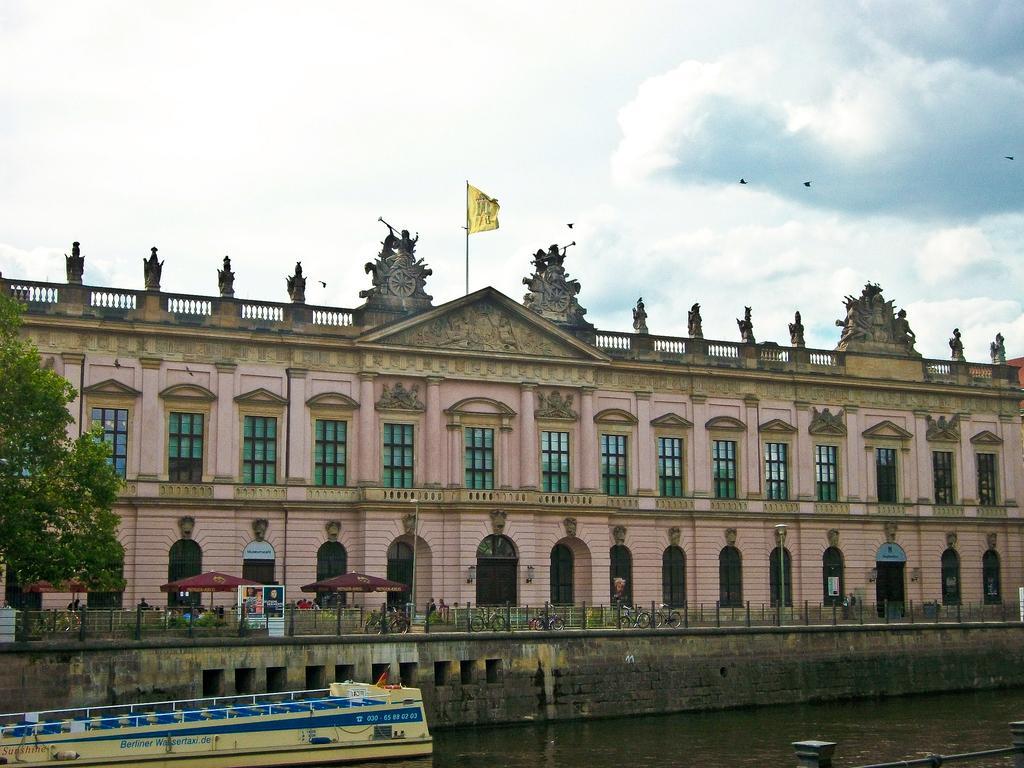Please provide a concise description of this image. In the center of the image there is a building. At the bottom of the image we can see road, tents, persons, cycles, ship and water. At the top of the building we can see a flag. In the background there are clouds and sky. 